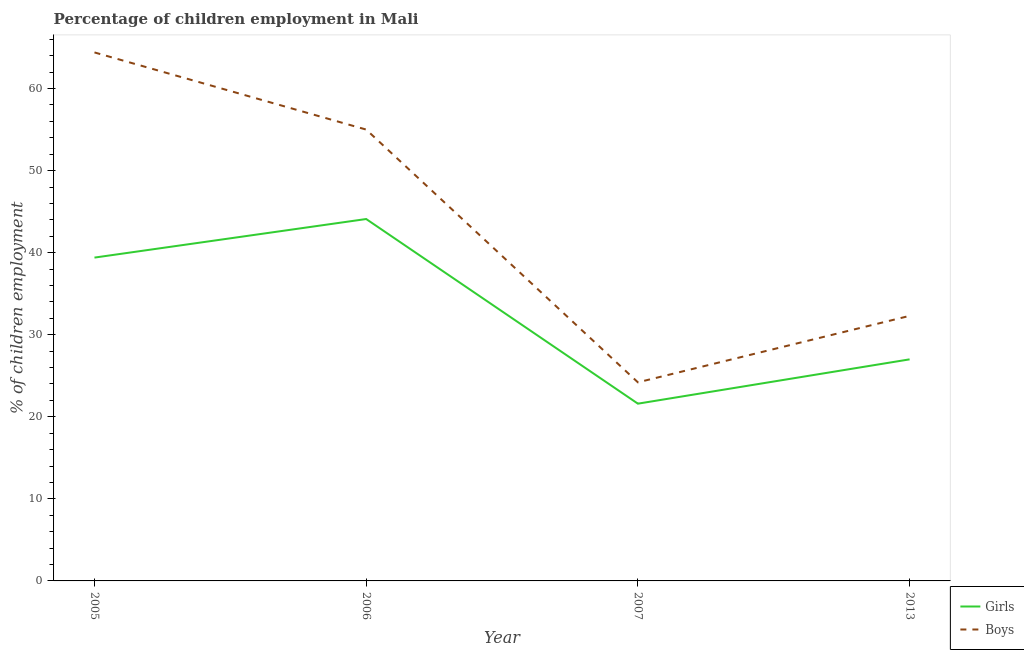How many different coloured lines are there?
Ensure brevity in your answer.  2. Does the line corresponding to percentage of employed girls intersect with the line corresponding to percentage of employed boys?
Keep it short and to the point. No. Is the number of lines equal to the number of legend labels?
Offer a very short reply. Yes. What is the percentage of employed girls in 2007?
Provide a short and direct response. 21.6. Across all years, what is the maximum percentage of employed girls?
Your answer should be compact. 44.1. Across all years, what is the minimum percentage of employed girls?
Offer a terse response. 21.6. What is the total percentage of employed boys in the graph?
Give a very brief answer. 175.9. What is the difference between the percentage of employed girls in 2005 and that in 2006?
Make the answer very short. -4.7. What is the difference between the percentage of employed girls in 2005 and the percentage of employed boys in 2007?
Provide a short and direct response. 15.2. What is the average percentage of employed boys per year?
Make the answer very short. 43.97. In the year 2005, what is the difference between the percentage of employed boys and percentage of employed girls?
Your response must be concise. 25. What is the ratio of the percentage of employed boys in 2005 to that in 2013?
Your answer should be very brief. 1.99. Is the percentage of employed boys in 2007 less than that in 2013?
Your answer should be compact. Yes. What is the difference between the highest and the second highest percentage of employed girls?
Provide a short and direct response. 4.7. What is the difference between the highest and the lowest percentage of employed girls?
Keep it short and to the point. 22.5. In how many years, is the percentage of employed boys greater than the average percentage of employed boys taken over all years?
Ensure brevity in your answer.  2. Is the percentage of employed boys strictly less than the percentage of employed girls over the years?
Provide a short and direct response. No. How many lines are there?
Keep it short and to the point. 2. How many years are there in the graph?
Offer a terse response. 4. What is the difference between two consecutive major ticks on the Y-axis?
Your answer should be compact. 10. Are the values on the major ticks of Y-axis written in scientific E-notation?
Offer a terse response. No. Where does the legend appear in the graph?
Make the answer very short. Bottom right. How many legend labels are there?
Ensure brevity in your answer.  2. How are the legend labels stacked?
Your answer should be compact. Vertical. What is the title of the graph?
Ensure brevity in your answer.  Percentage of children employment in Mali. Does "Public funds" appear as one of the legend labels in the graph?
Offer a very short reply. No. What is the label or title of the Y-axis?
Your response must be concise. % of children employment. What is the % of children employment in Girls in 2005?
Your response must be concise. 39.4. What is the % of children employment in Boys in 2005?
Your response must be concise. 64.4. What is the % of children employment of Girls in 2006?
Offer a very short reply. 44.1. What is the % of children employment in Girls in 2007?
Keep it short and to the point. 21.6. What is the % of children employment of Boys in 2007?
Your answer should be compact. 24.2. What is the % of children employment in Boys in 2013?
Ensure brevity in your answer.  32.3. Across all years, what is the maximum % of children employment in Girls?
Ensure brevity in your answer.  44.1. Across all years, what is the maximum % of children employment of Boys?
Offer a terse response. 64.4. Across all years, what is the minimum % of children employment in Girls?
Your answer should be compact. 21.6. Across all years, what is the minimum % of children employment in Boys?
Ensure brevity in your answer.  24.2. What is the total % of children employment in Girls in the graph?
Give a very brief answer. 132.1. What is the total % of children employment of Boys in the graph?
Ensure brevity in your answer.  175.9. What is the difference between the % of children employment in Girls in 2005 and that in 2006?
Provide a succinct answer. -4.7. What is the difference between the % of children employment in Boys in 2005 and that in 2006?
Give a very brief answer. 9.4. What is the difference between the % of children employment of Girls in 2005 and that in 2007?
Your response must be concise. 17.8. What is the difference between the % of children employment in Boys in 2005 and that in 2007?
Make the answer very short. 40.2. What is the difference between the % of children employment of Girls in 2005 and that in 2013?
Your answer should be compact. 12.4. What is the difference between the % of children employment in Boys in 2005 and that in 2013?
Your response must be concise. 32.1. What is the difference between the % of children employment in Boys in 2006 and that in 2007?
Offer a terse response. 30.8. What is the difference between the % of children employment of Boys in 2006 and that in 2013?
Ensure brevity in your answer.  22.7. What is the difference between the % of children employment in Girls in 2005 and the % of children employment in Boys in 2006?
Ensure brevity in your answer.  -15.6. What is the difference between the % of children employment of Girls in 2005 and the % of children employment of Boys in 2007?
Offer a very short reply. 15.2. What is the difference between the % of children employment in Girls in 2006 and the % of children employment in Boys in 2013?
Offer a very short reply. 11.8. What is the difference between the % of children employment in Girls in 2007 and the % of children employment in Boys in 2013?
Keep it short and to the point. -10.7. What is the average % of children employment of Girls per year?
Offer a terse response. 33.02. What is the average % of children employment in Boys per year?
Offer a terse response. 43.98. In the year 2005, what is the difference between the % of children employment in Girls and % of children employment in Boys?
Provide a short and direct response. -25. In the year 2006, what is the difference between the % of children employment of Girls and % of children employment of Boys?
Your answer should be very brief. -10.9. In the year 2013, what is the difference between the % of children employment in Girls and % of children employment in Boys?
Give a very brief answer. -5.3. What is the ratio of the % of children employment of Girls in 2005 to that in 2006?
Provide a succinct answer. 0.89. What is the ratio of the % of children employment of Boys in 2005 to that in 2006?
Your answer should be very brief. 1.17. What is the ratio of the % of children employment in Girls in 2005 to that in 2007?
Ensure brevity in your answer.  1.82. What is the ratio of the % of children employment in Boys in 2005 to that in 2007?
Offer a terse response. 2.66. What is the ratio of the % of children employment of Girls in 2005 to that in 2013?
Offer a terse response. 1.46. What is the ratio of the % of children employment of Boys in 2005 to that in 2013?
Keep it short and to the point. 1.99. What is the ratio of the % of children employment in Girls in 2006 to that in 2007?
Provide a short and direct response. 2.04. What is the ratio of the % of children employment in Boys in 2006 to that in 2007?
Provide a succinct answer. 2.27. What is the ratio of the % of children employment in Girls in 2006 to that in 2013?
Your response must be concise. 1.63. What is the ratio of the % of children employment in Boys in 2006 to that in 2013?
Provide a succinct answer. 1.7. What is the ratio of the % of children employment in Girls in 2007 to that in 2013?
Provide a succinct answer. 0.8. What is the ratio of the % of children employment in Boys in 2007 to that in 2013?
Give a very brief answer. 0.75. What is the difference between the highest and the second highest % of children employment in Girls?
Ensure brevity in your answer.  4.7. What is the difference between the highest and the lowest % of children employment of Boys?
Your response must be concise. 40.2. 